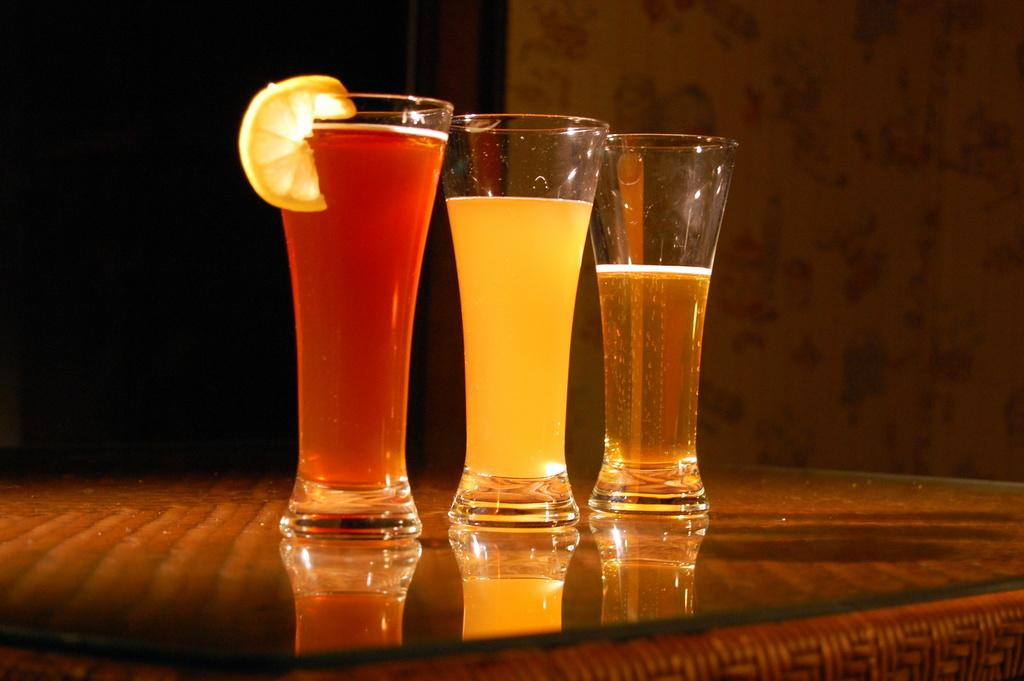How many glasses are on the table in the image? There are three glasses on the table in the image. What is inside the glasses? There are liquids in the glasses. What is the color of the table? The table is brown in color. What type of umbrella is being used to protect the glasses from the rain in the image? There is no umbrella present in the image, and the glasses are not being protected from the rain. 